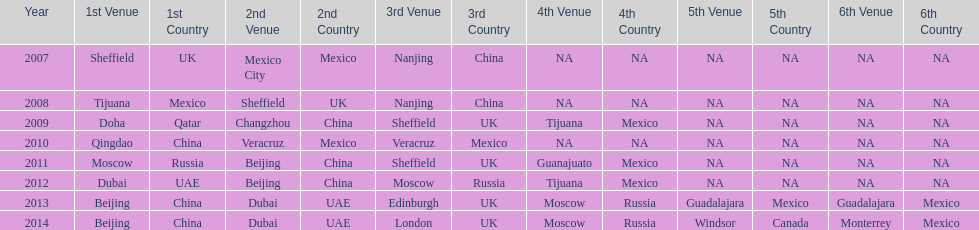In which most recent year did tijuana serve as a venue? 2012. Could you parse the entire table? {'header': ['Year', '1st Venue', '1st Country', '2nd Venue', '2nd Country', '3rd Venue', '3rd Country', '4th Venue', '4th Country', '5th Venue', '5th Country', '6th Venue', '6th Country'], 'rows': [['2007', 'Sheffield', 'UK', 'Mexico City', 'Mexico', 'Nanjing', 'China', 'NA', 'NA', 'NA', 'NA', 'NA', 'NA'], ['2008', 'Tijuana', 'Mexico', 'Sheffield', 'UK', 'Nanjing', 'China', 'NA', 'NA', 'NA', 'NA', 'NA', 'NA'], ['2009', 'Doha', 'Qatar', 'Changzhou', 'China', 'Sheffield', 'UK', 'Tijuana', 'Mexico', 'NA', 'NA', 'NA', 'NA'], ['2010', 'Qingdao', 'China', 'Veracruz', 'Mexico', 'Veracruz', 'Mexico', 'NA', 'NA', 'NA', 'NA', 'NA', 'NA'], ['2011', 'Moscow', 'Russia', 'Beijing', 'China', 'Sheffield', 'UK', 'Guanajuato', 'Mexico', 'NA', 'NA', 'NA', 'NA'], ['2012', 'Dubai', 'UAE', 'Beijing', 'China', 'Moscow', 'Russia', 'Tijuana', 'Mexico', 'NA', 'NA', 'NA', 'NA'], ['2013', 'Beijing', 'China', 'Dubai', 'UAE', 'Edinburgh', 'UK', 'Moscow', 'Russia', 'Guadalajara', 'Mexico', 'Guadalajara', 'Mexico'], ['2014', 'Beijing', 'China', 'Dubai', 'UAE', 'London', 'UK', 'Moscow', 'Russia', 'Windsor', 'Canada', 'Monterrey', 'Mexico']]} 